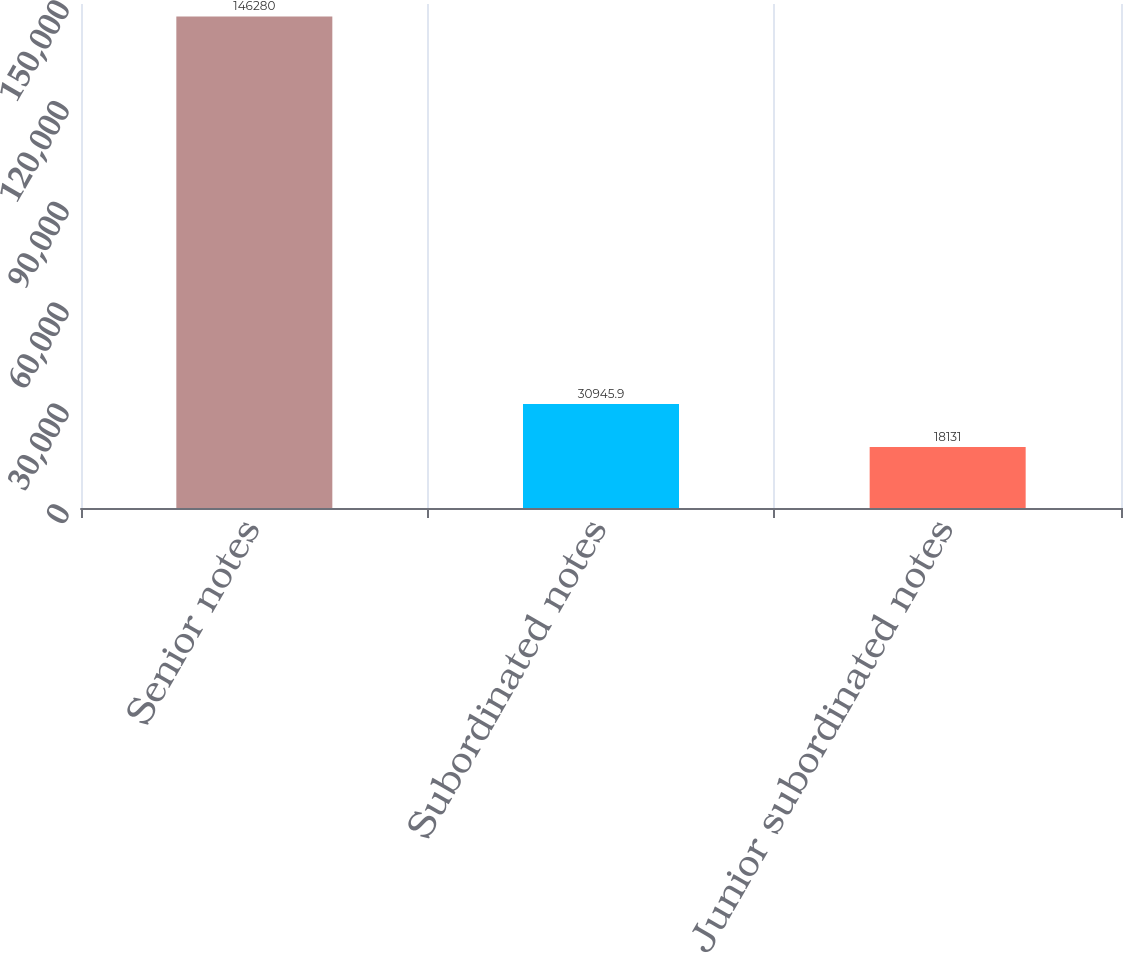<chart> <loc_0><loc_0><loc_500><loc_500><bar_chart><fcel>Senior notes<fcel>Subordinated notes<fcel>Junior subordinated notes<nl><fcel>146280<fcel>30945.9<fcel>18131<nl></chart> 